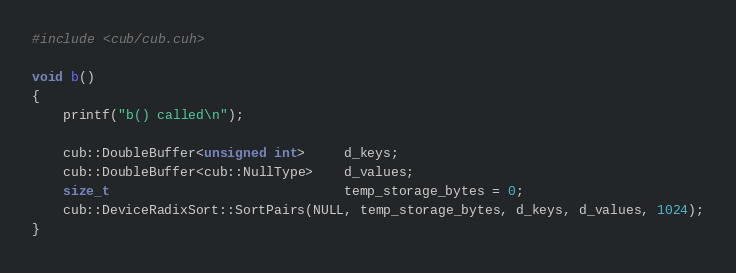Convert code to text. <code><loc_0><loc_0><loc_500><loc_500><_Cuda_>#include <cub/cub.cuh>

void b()
{
    printf("b() called\n");

    cub::DoubleBuffer<unsigned int>     d_keys;
    cub::DoubleBuffer<cub::NullType>    d_values;
    size_t                              temp_storage_bytes = 0;
    cub::DeviceRadixSort::SortPairs(NULL, temp_storage_bytes, d_keys, d_values, 1024);
}
</code> 